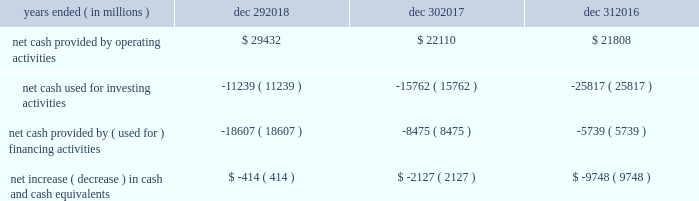Sources and uses of cash ( in millions ) in summary , our cash flows for each period were as follows : years ended ( in millions ) dec 29 , dec 30 , dec 31 .
Md&a consolidated results and analysis 40 .
As of december 292017 what was the percent of the net cash provided by ( used for ) financing activities to the net cash provided by operating activities? 
Rationale: as of december 292017 38.3% of net cash provided by operating activities was used for the ( used for ) financing activities
Computations: (8475 / 22110)
Answer: 0.38331. 